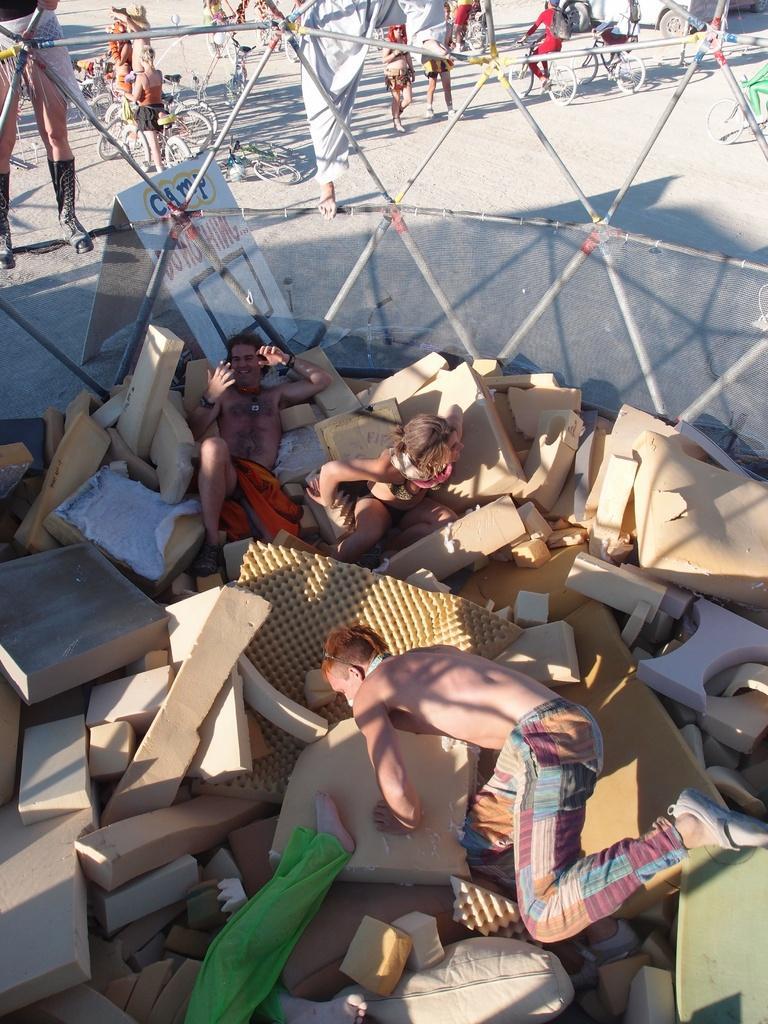Please provide a concise description of this image. In this image we can see some people on the sponge blocks which are kept in the mesh. We can also see two persons standing beside the metal poles. On the backside we can see a board with some text on it, two persons standing and a group of people riding bicycles on the road. 